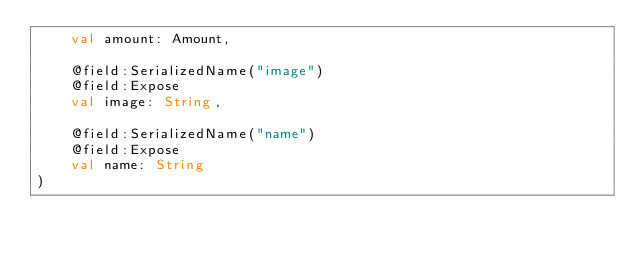<code> <loc_0><loc_0><loc_500><loc_500><_Kotlin_>    val amount: Amount,
    
    @field:SerializedName("image")
    @field:Expose
    val image: String,
    
    @field:SerializedName("name")
    @field:Expose
    val name: String
)</code> 